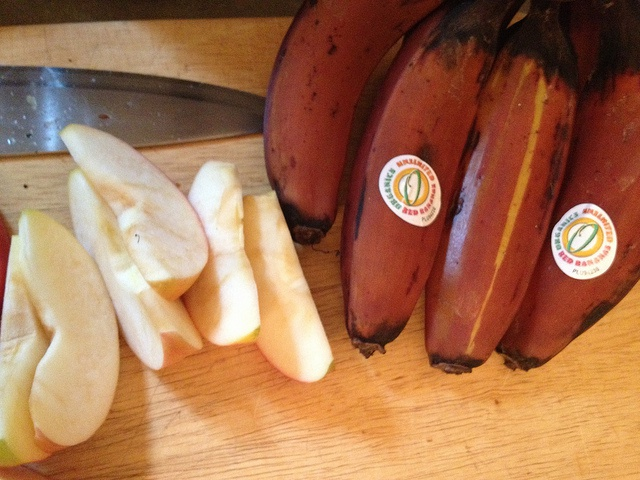Describe the objects in this image and their specific colors. I can see banana in maroon, brown, and black tones, dining table in maroon, orange, brown, and tan tones, apple in maroon, lightgray, and tan tones, knife in maroon, gray, and black tones, and apple in maroon, tan, and beige tones in this image. 